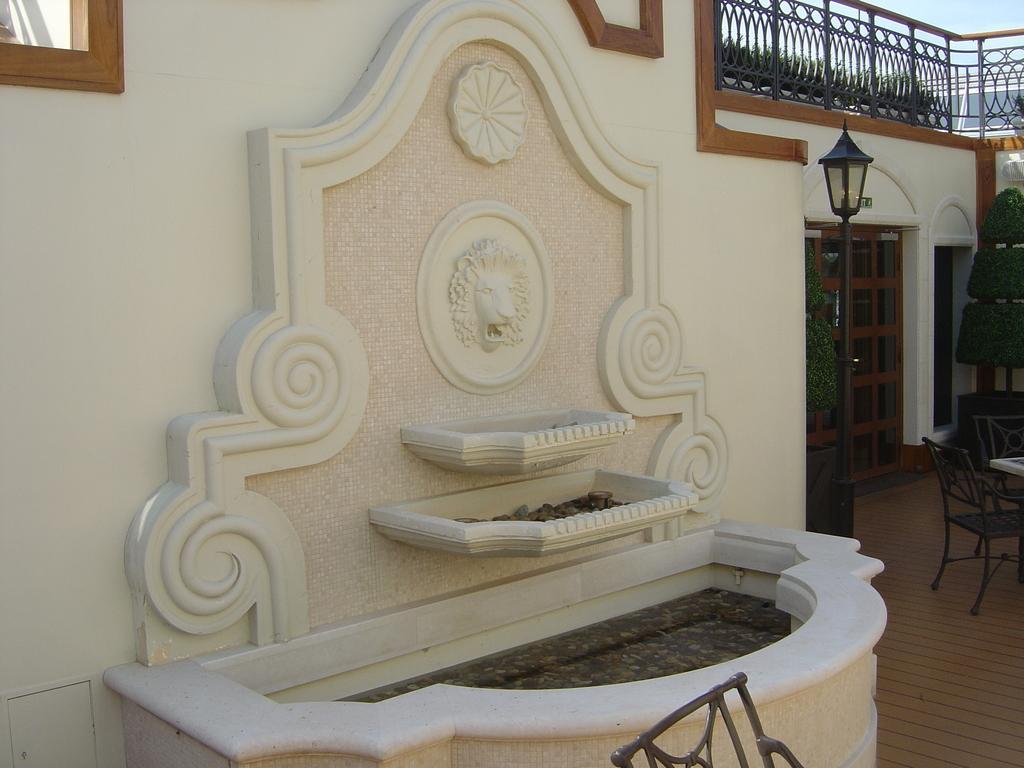Describe this image in one or two sentences. In the image there is a water sink in the front and in the back there is table with chairs around it with a street beside it on the floor followed by doors on the wall with a fence above it. 